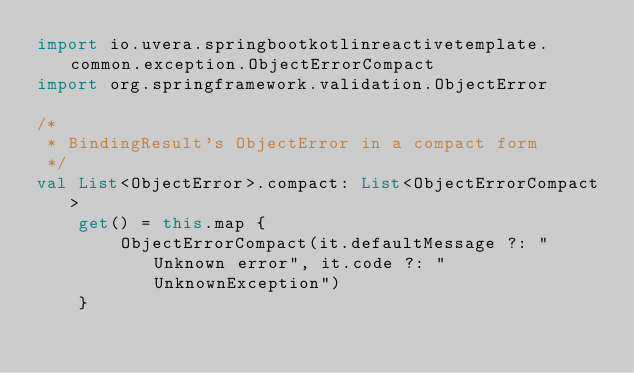<code> <loc_0><loc_0><loc_500><loc_500><_Kotlin_>import io.uvera.springbootkotlinreactivetemplate.common.exception.ObjectErrorCompact
import org.springframework.validation.ObjectError

/*
 * BindingResult's ObjectError in a compact form
 */
val List<ObjectError>.compact: List<ObjectErrorCompact>
    get() = this.map {
        ObjectErrorCompact(it.defaultMessage ?: "Unknown error", it.code ?: "UnknownException")
    }
</code> 